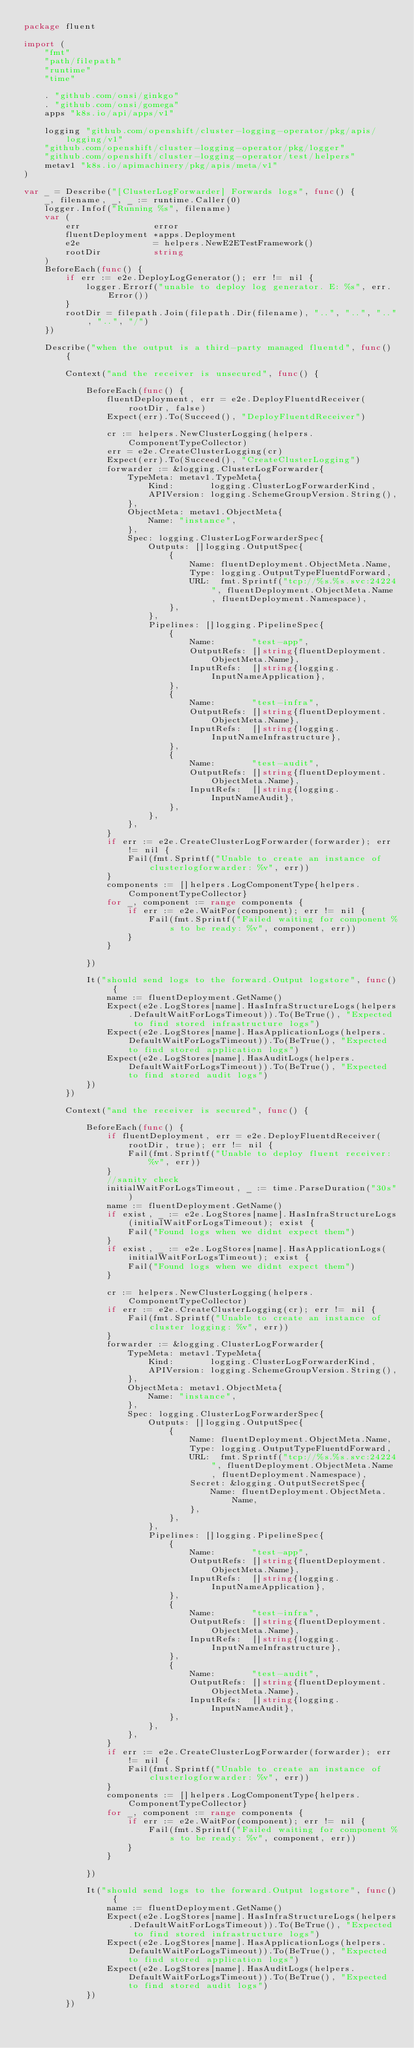<code> <loc_0><loc_0><loc_500><loc_500><_Go_>package fluent

import (
	"fmt"
	"path/filepath"
	"runtime"
	"time"

	. "github.com/onsi/ginkgo"
	. "github.com/onsi/gomega"
	apps "k8s.io/api/apps/v1"

	logging "github.com/openshift/cluster-logging-operator/pkg/apis/logging/v1"
	"github.com/openshift/cluster-logging-operator/pkg/logger"
	"github.com/openshift/cluster-logging-operator/test/helpers"
	metav1 "k8s.io/apimachinery/pkg/apis/meta/v1"
)

var _ = Describe("[ClusterLogForwarder] Forwards logs", func() {
	_, filename, _, _ := runtime.Caller(0)
	logger.Infof("Running %s", filename)
	var (
		err              error
		fluentDeployment *apps.Deployment
		e2e              = helpers.NewE2ETestFramework()
		rootDir          string
	)
	BeforeEach(func() {
		if err := e2e.DeployLogGenerator(); err != nil {
			logger.Errorf("unable to deploy log generator. E: %s", err.Error())
		}
		rootDir = filepath.Join(filepath.Dir(filename), "..", "..", "..", "..", "/")
	})

	Describe("when the output is a third-party managed fluentd", func() {

		Context("and the receiver is unsecured", func() {

			BeforeEach(func() {
				fluentDeployment, err = e2e.DeployFluentdReceiver(rootDir, false)
				Expect(err).To(Succeed(), "DeployFluentdReceiver")

				cr := helpers.NewClusterLogging(helpers.ComponentTypeCollector)
				err = e2e.CreateClusterLogging(cr)
				Expect(err).To(Succeed(), "CreateClusterLogging")
				forwarder := &logging.ClusterLogForwarder{
					TypeMeta: metav1.TypeMeta{
						Kind:       logging.ClusterLogForwarderKind,
						APIVersion: logging.SchemeGroupVersion.String(),
					},
					ObjectMeta: metav1.ObjectMeta{
						Name: "instance",
					},
					Spec: logging.ClusterLogForwarderSpec{
						Outputs: []logging.OutputSpec{
							{
								Name: fluentDeployment.ObjectMeta.Name,
								Type: logging.OutputTypeFluentdForward,
								URL:  fmt.Sprintf("tcp://%s.%s.svc:24224", fluentDeployment.ObjectMeta.Name, fluentDeployment.Namespace),
							},
						},
						Pipelines: []logging.PipelineSpec{
							{
								Name:       "test-app",
								OutputRefs: []string{fluentDeployment.ObjectMeta.Name},
								InputRefs:  []string{logging.InputNameApplication},
							},
							{
								Name:       "test-infra",
								OutputRefs: []string{fluentDeployment.ObjectMeta.Name},
								InputRefs:  []string{logging.InputNameInfrastructure},
							},
							{
								Name:       "test-audit",
								OutputRefs: []string{fluentDeployment.ObjectMeta.Name},
								InputRefs:  []string{logging.InputNameAudit},
							},
						},
					},
				}
				if err := e2e.CreateClusterLogForwarder(forwarder); err != nil {
					Fail(fmt.Sprintf("Unable to create an instance of clusterlogforwarder: %v", err))
				}
				components := []helpers.LogComponentType{helpers.ComponentTypeCollector}
				for _, component := range components {
					if err := e2e.WaitFor(component); err != nil {
						Fail(fmt.Sprintf("Failed waiting for component %s to be ready: %v", component, err))
					}
				}

			})

			It("should send logs to the forward.Output logstore", func() {
				name := fluentDeployment.GetName()
				Expect(e2e.LogStores[name].HasInfraStructureLogs(helpers.DefaultWaitForLogsTimeout)).To(BeTrue(), "Expected to find stored infrastructure logs")
				Expect(e2e.LogStores[name].HasApplicationLogs(helpers.DefaultWaitForLogsTimeout)).To(BeTrue(), "Expected to find stored application logs")
				Expect(e2e.LogStores[name].HasAuditLogs(helpers.DefaultWaitForLogsTimeout)).To(BeTrue(), "Expected to find stored audit logs")
			})
		})

		Context("and the receiver is secured", func() {

			BeforeEach(func() {
				if fluentDeployment, err = e2e.DeployFluentdReceiver(rootDir, true); err != nil {
					Fail(fmt.Sprintf("Unable to deploy fluent receiver: %v", err))
				}
				//sanity check
				initialWaitForLogsTimeout, _ := time.ParseDuration("30s")
				name := fluentDeployment.GetName()
				if exist, _ := e2e.LogStores[name].HasInfraStructureLogs(initialWaitForLogsTimeout); exist {
					Fail("Found logs when we didnt expect them")
				}
				if exist, _ := e2e.LogStores[name].HasApplicationLogs(initialWaitForLogsTimeout); exist {
					Fail("Found logs when we didnt expect them")
				}

				cr := helpers.NewClusterLogging(helpers.ComponentTypeCollector)
				if err := e2e.CreateClusterLogging(cr); err != nil {
					Fail(fmt.Sprintf("Unable to create an instance of cluster logging: %v", err))
				}
				forwarder := &logging.ClusterLogForwarder{
					TypeMeta: metav1.TypeMeta{
						Kind:       logging.ClusterLogForwarderKind,
						APIVersion: logging.SchemeGroupVersion.String(),
					},
					ObjectMeta: metav1.ObjectMeta{
						Name: "instance",
					},
					Spec: logging.ClusterLogForwarderSpec{
						Outputs: []logging.OutputSpec{
							{
								Name: fluentDeployment.ObjectMeta.Name,
								Type: logging.OutputTypeFluentdForward,
								URL:  fmt.Sprintf("tcp://%s.%s.svc:24224", fluentDeployment.ObjectMeta.Name, fluentDeployment.Namespace),
								Secret: &logging.OutputSecretSpec{
									Name: fluentDeployment.ObjectMeta.Name,
								},
							},
						},
						Pipelines: []logging.PipelineSpec{
							{
								Name:       "test-app",
								OutputRefs: []string{fluentDeployment.ObjectMeta.Name},
								InputRefs:  []string{logging.InputNameApplication},
							},
							{
								Name:       "test-infra",
								OutputRefs: []string{fluentDeployment.ObjectMeta.Name},
								InputRefs:  []string{logging.InputNameInfrastructure},
							},
							{
								Name:       "test-audit",
								OutputRefs: []string{fluentDeployment.ObjectMeta.Name},
								InputRefs:  []string{logging.InputNameAudit},
							},
						},
					},
				}
				if err := e2e.CreateClusterLogForwarder(forwarder); err != nil {
					Fail(fmt.Sprintf("Unable to create an instance of clusterlogforwarder: %v", err))
				}
				components := []helpers.LogComponentType{helpers.ComponentTypeCollector}
				for _, component := range components {
					if err := e2e.WaitFor(component); err != nil {
						Fail(fmt.Sprintf("Failed waiting for component %s to be ready: %v", component, err))
					}
				}

			})

			It("should send logs to the forward.Output logstore", func() {
				name := fluentDeployment.GetName()
				Expect(e2e.LogStores[name].HasInfraStructureLogs(helpers.DefaultWaitForLogsTimeout)).To(BeTrue(), "Expected to find stored infrastructure logs")
				Expect(e2e.LogStores[name].HasApplicationLogs(helpers.DefaultWaitForLogsTimeout)).To(BeTrue(), "Expected to find stored application logs")
				Expect(e2e.LogStores[name].HasAuditLogs(helpers.DefaultWaitForLogsTimeout)).To(BeTrue(), "Expected to find stored audit logs")
			})
		})
</code> 